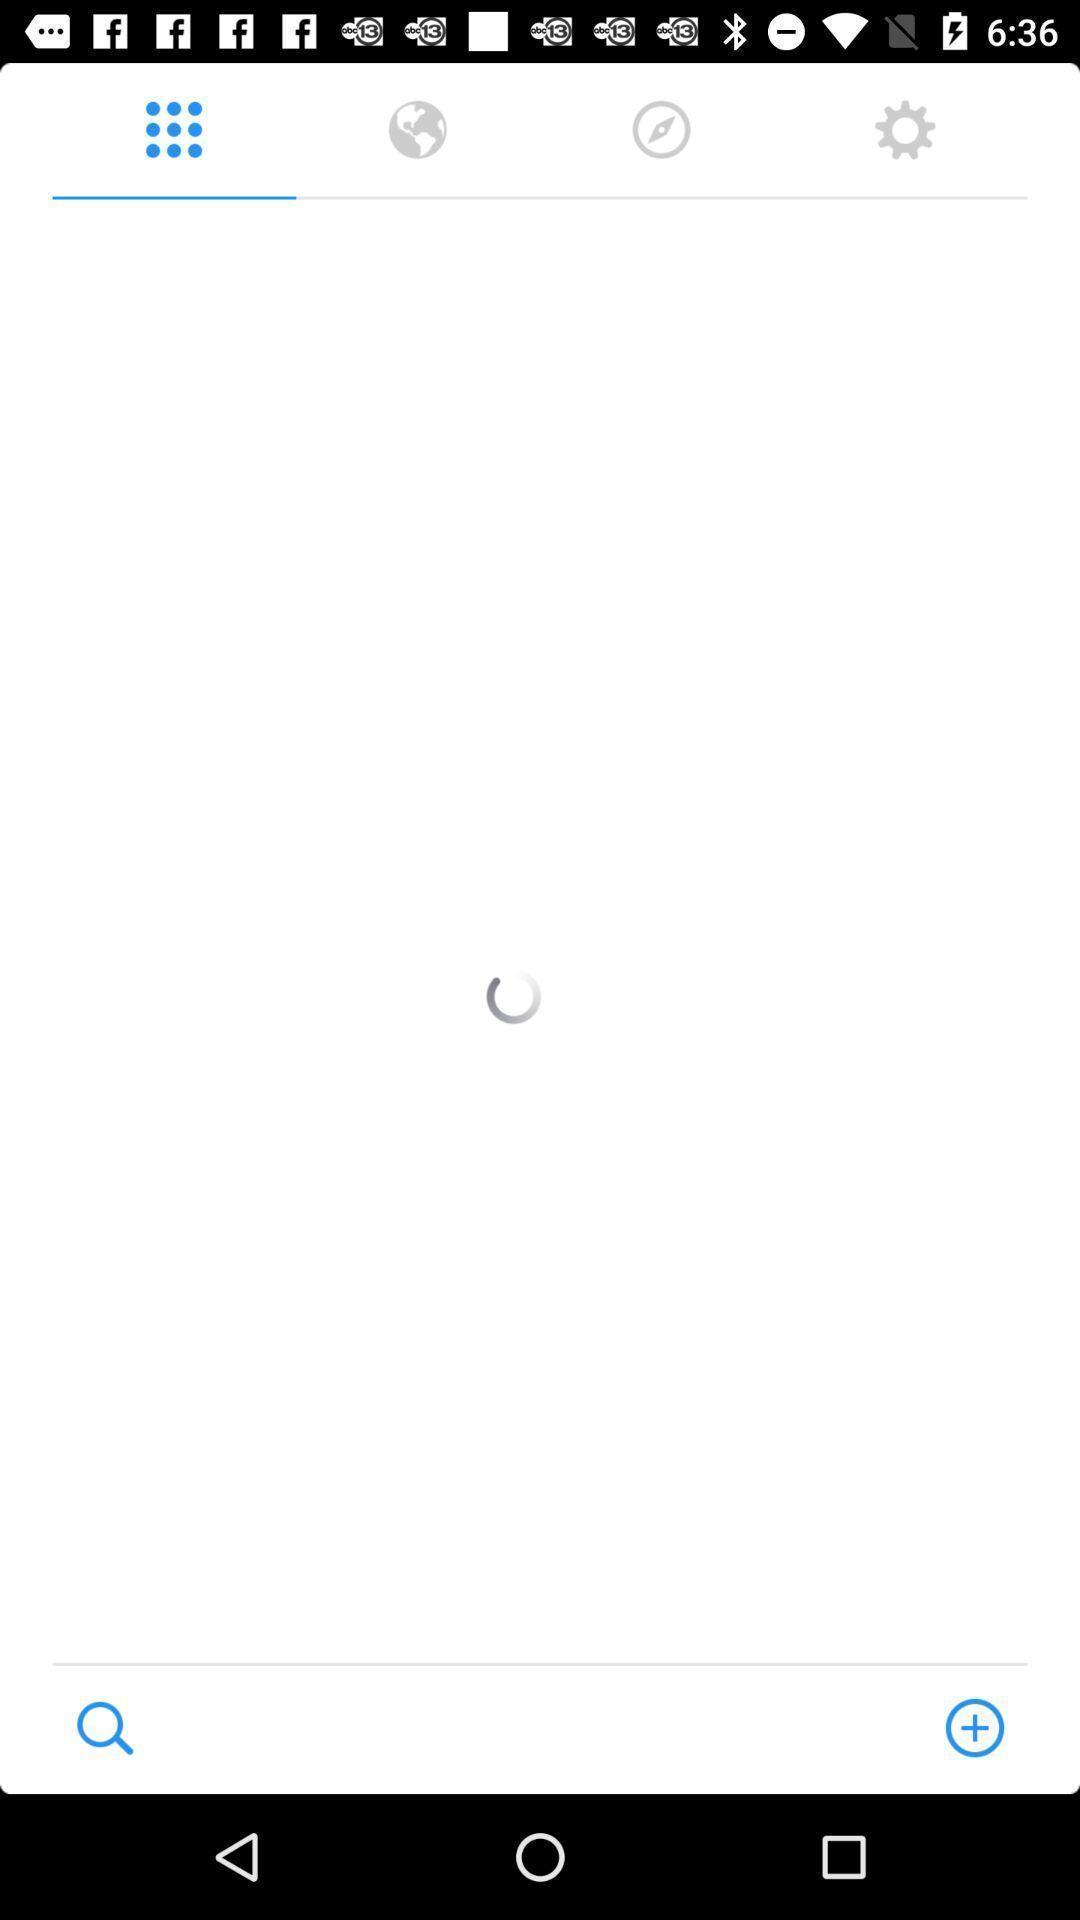Describe the content in this image. Page that is still loading with different icons. 